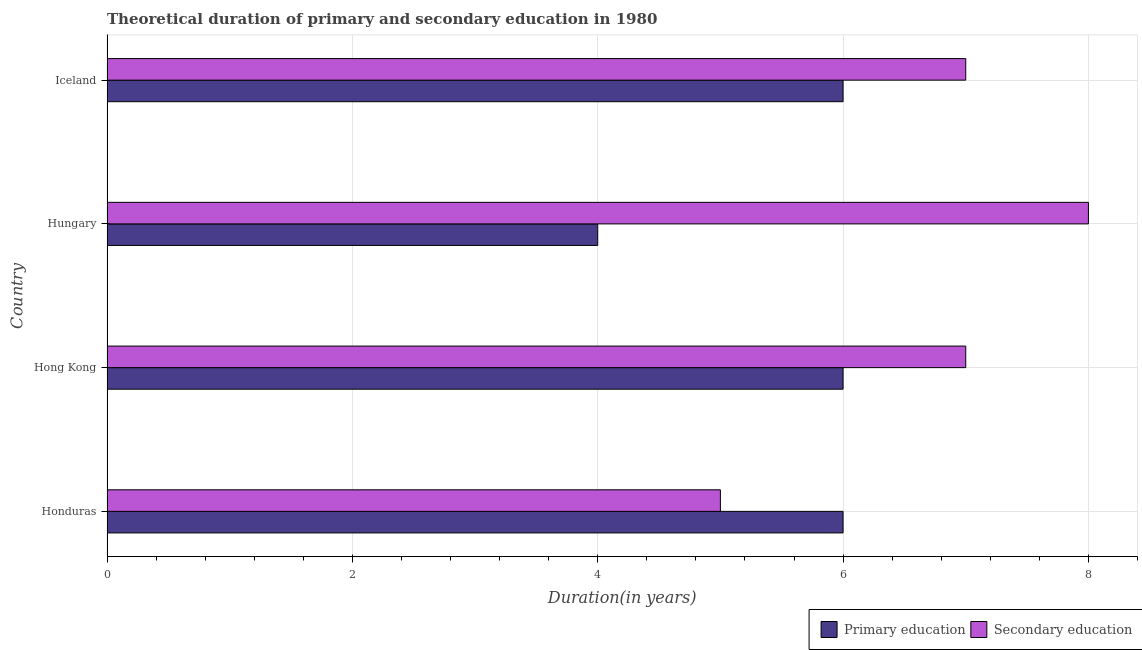How many different coloured bars are there?
Offer a very short reply. 2. How many groups of bars are there?
Give a very brief answer. 4. How many bars are there on the 1st tick from the top?
Provide a succinct answer. 2. How many bars are there on the 2nd tick from the bottom?
Make the answer very short. 2. What is the label of the 3rd group of bars from the top?
Your response must be concise. Hong Kong. In how many cases, is the number of bars for a given country not equal to the number of legend labels?
Provide a short and direct response. 0. What is the duration of secondary education in Honduras?
Your answer should be compact. 5. Across all countries, what is the maximum duration of secondary education?
Make the answer very short. 8. Across all countries, what is the minimum duration of secondary education?
Keep it short and to the point. 5. In which country was the duration of primary education maximum?
Give a very brief answer. Honduras. In which country was the duration of primary education minimum?
Offer a terse response. Hungary. What is the total duration of secondary education in the graph?
Provide a short and direct response. 27. What is the difference between the duration of primary education in Honduras and that in Hungary?
Provide a succinct answer. 2. What is the difference between the duration of primary education in Hungary and the duration of secondary education in Iceland?
Offer a terse response. -3. What is the difference between the duration of primary education and duration of secondary education in Iceland?
Provide a short and direct response. -1. In how many countries, is the duration of secondary education greater than 8 years?
Offer a terse response. 0. What is the ratio of the duration of secondary education in Hong Kong to that in Iceland?
Provide a succinct answer. 1. Is the duration of secondary education in Hong Kong less than that in Hungary?
Keep it short and to the point. Yes. Is the difference between the duration of primary education in Hungary and Iceland greater than the difference between the duration of secondary education in Hungary and Iceland?
Offer a very short reply. No. What is the difference between the highest and the lowest duration of primary education?
Provide a succinct answer. 2. What does the 1st bar from the top in Hong Kong represents?
Ensure brevity in your answer.  Secondary education. How many countries are there in the graph?
Your answer should be very brief. 4. What is the difference between two consecutive major ticks on the X-axis?
Your answer should be compact. 2. Are the values on the major ticks of X-axis written in scientific E-notation?
Offer a very short reply. No. Does the graph contain any zero values?
Keep it short and to the point. No. Does the graph contain grids?
Keep it short and to the point. Yes. How many legend labels are there?
Keep it short and to the point. 2. What is the title of the graph?
Keep it short and to the point. Theoretical duration of primary and secondary education in 1980. What is the label or title of the X-axis?
Keep it short and to the point. Duration(in years). What is the Duration(in years) in Secondary education in Honduras?
Make the answer very short. 5. What is the Duration(in years) of Primary education in Hungary?
Your answer should be compact. 4. What is the Duration(in years) of Secondary education in Hungary?
Your answer should be very brief. 8. What is the Duration(in years) in Primary education in Iceland?
Your response must be concise. 6. What is the Duration(in years) of Secondary education in Iceland?
Keep it short and to the point. 7. Across all countries, what is the minimum Duration(in years) of Primary education?
Your answer should be compact. 4. What is the difference between the Duration(in years) in Primary education in Honduras and that in Hong Kong?
Offer a terse response. 0. What is the difference between the Duration(in years) of Secondary education in Honduras and that in Hong Kong?
Ensure brevity in your answer.  -2. What is the difference between the Duration(in years) in Secondary education in Honduras and that in Hungary?
Offer a very short reply. -3. What is the difference between the Duration(in years) in Secondary education in Honduras and that in Iceland?
Your answer should be compact. -2. What is the difference between the Duration(in years) of Secondary education in Hong Kong and that in Hungary?
Give a very brief answer. -1. What is the difference between the Duration(in years) of Primary education in Hong Kong and that in Iceland?
Make the answer very short. 0. What is the difference between the Duration(in years) in Primary education in Hungary and that in Iceland?
Your answer should be very brief. -2. What is the difference between the Duration(in years) of Secondary education in Hungary and that in Iceland?
Provide a succinct answer. 1. What is the difference between the Duration(in years) in Primary education in Honduras and the Duration(in years) in Secondary education in Hong Kong?
Provide a succinct answer. -1. What is the difference between the Duration(in years) in Primary education in Hong Kong and the Duration(in years) in Secondary education in Hungary?
Keep it short and to the point. -2. What is the average Duration(in years) in Secondary education per country?
Your answer should be compact. 6.75. What is the difference between the Duration(in years) in Primary education and Duration(in years) in Secondary education in Honduras?
Give a very brief answer. 1. What is the ratio of the Duration(in years) of Primary education in Honduras to that in Hong Kong?
Your answer should be very brief. 1. What is the ratio of the Duration(in years) of Primary education in Honduras to that in Iceland?
Make the answer very short. 1. What is the ratio of the Duration(in years) of Secondary education in Honduras to that in Iceland?
Offer a terse response. 0.71. What is the ratio of the Duration(in years) of Secondary education in Hong Kong to that in Hungary?
Your answer should be very brief. 0.88. What is the ratio of the Duration(in years) of Primary education in Hong Kong to that in Iceland?
Keep it short and to the point. 1. What is the ratio of the Duration(in years) in Primary education in Hungary to that in Iceland?
Your answer should be very brief. 0.67. What is the ratio of the Duration(in years) of Secondary education in Hungary to that in Iceland?
Offer a terse response. 1.14. What is the difference between the highest and the second highest Duration(in years) of Secondary education?
Provide a succinct answer. 1. What is the difference between the highest and the lowest Duration(in years) of Secondary education?
Make the answer very short. 3. 